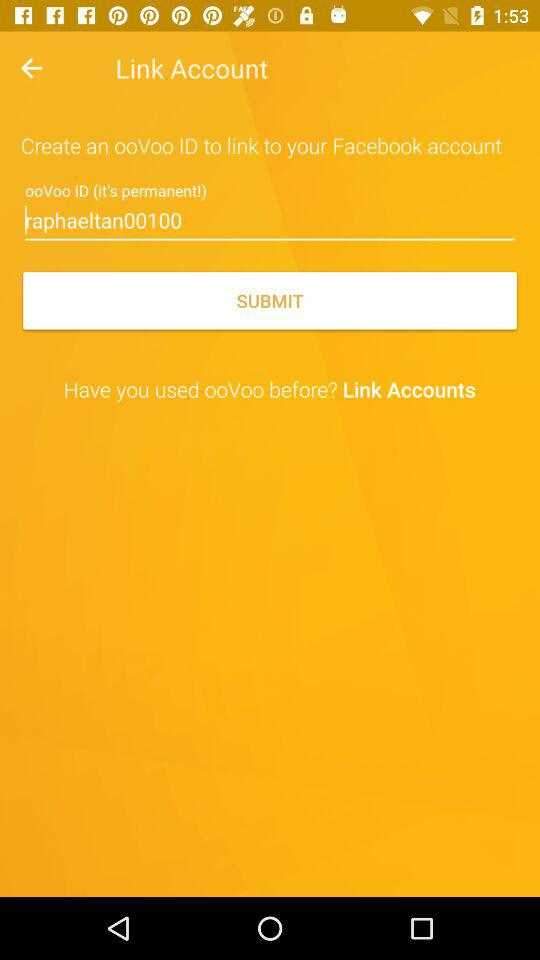What is the ooVoo id? The ooVoo id is raphaeltan00100. 